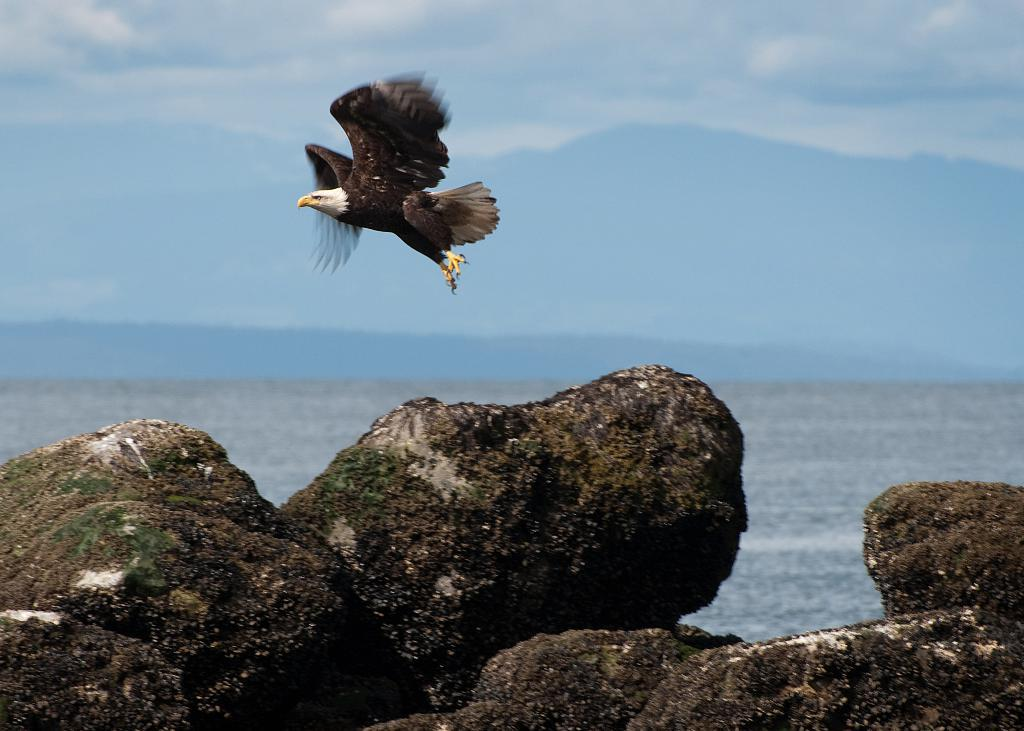What is located in the foreground of the image? There are rocks and a water body in the foreground of the image. What can be seen in the middle of the image? There is an eagle flying in the middle of the image. What is visible at the top of the image? The sky is visible at the top of the image. What type of house can be seen in the background of the image? There is no house present in the image; it features rocks, a water body, an eagle, and the sky. What songs is the eagle singing while flying in the image? Eagles do not sing songs, and there is no indication in the image that the eagle is singing or making any sounds. 